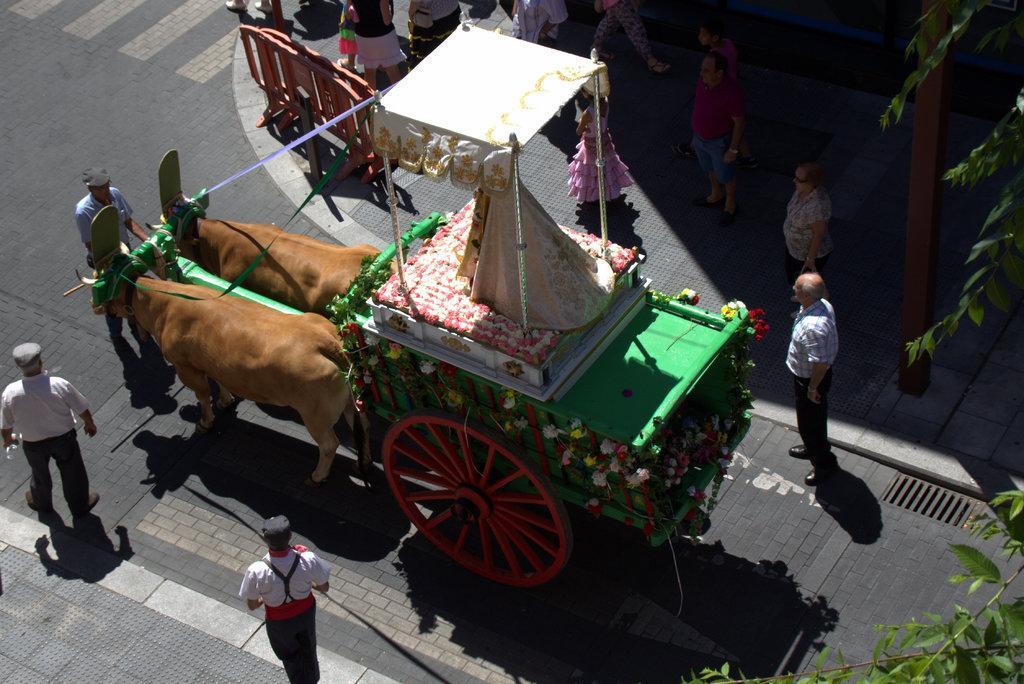Describe this image in one or two sentences. In the picture I can see the top view in which we can see the animal cart which is moving on the road. Here we can see these people are standing on the road, we can see trees, road barriers, these people walking on the sidewalk and this part of the image is dark. 